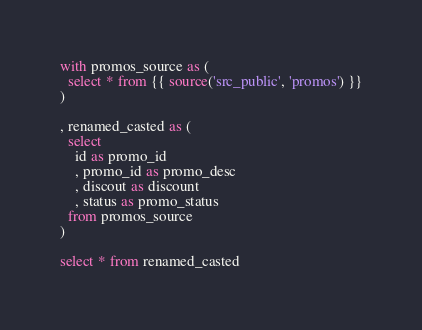Convert code to text. <code><loc_0><loc_0><loc_500><loc_500><_SQL_>with promos_source as (
  select * from {{ source('src_public', 'promos') }}
)

, renamed_casted as (
  select
    id as promo_id
    , promo_id as promo_desc
    , discout as discount
    , status as promo_status
  from promos_source
)

select * from renamed_casted</code> 